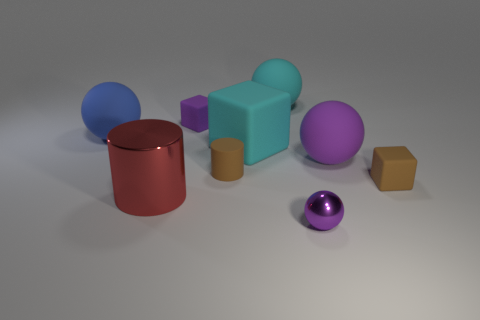Subtract all yellow balls. Subtract all purple cubes. How many balls are left? 4 Subtract all spheres. How many objects are left? 5 Subtract all brown rubber cylinders. Subtract all red metal things. How many objects are left? 7 Add 3 big cyan matte cubes. How many big cyan matte cubes are left? 4 Add 9 red shiny cylinders. How many red shiny cylinders exist? 10 Subtract 0 red spheres. How many objects are left? 9 